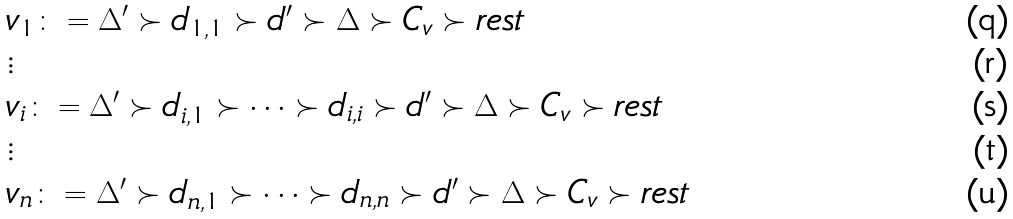Convert formula to latex. <formula><loc_0><loc_0><loc_500><loc_500>& v _ { 1 } \colon = \Delta ^ { \prime } \succ d _ { 1 , 1 } \succ d ^ { \prime } \succ \Delta \succ C _ { v } \succ r e s t \\ & \vdots \\ & v _ { i } \colon = \Delta ^ { \prime } \succ d _ { i , 1 } \succ \dots \succ d _ { i , i } \succ d ^ { \prime } \succ \Delta \succ C _ { v } \succ r e s t \\ & \vdots \\ & v _ { n } \colon = \Delta ^ { \prime } \succ d _ { n , 1 } \succ \dots \succ d _ { n , n } \succ d ^ { \prime } \succ \Delta \succ C _ { v } \succ r e s t</formula> 